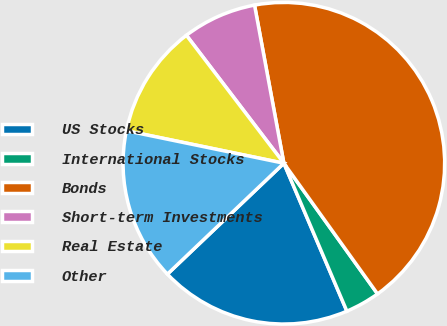Convert chart to OTSL. <chart><loc_0><loc_0><loc_500><loc_500><pie_chart><fcel>US Stocks<fcel>International Stocks<fcel>Bonds<fcel>Short-term Investments<fcel>Real Estate<fcel>Other<nl><fcel>19.3%<fcel>3.49%<fcel>43.02%<fcel>7.44%<fcel>11.4%<fcel>15.35%<nl></chart> 